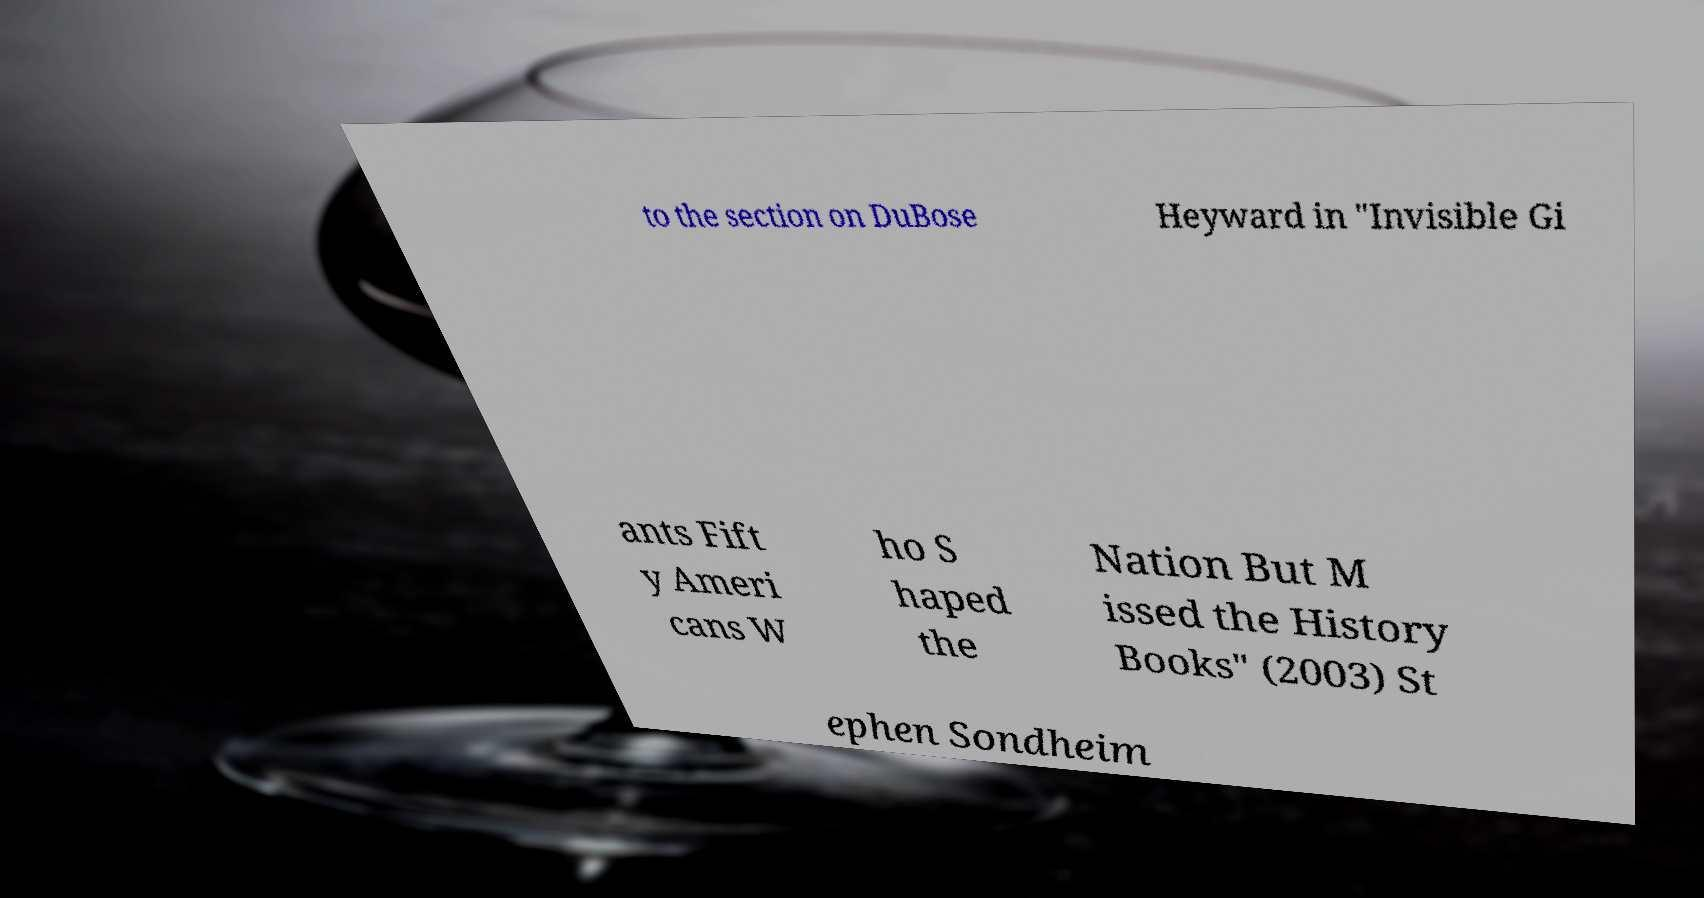For documentation purposes, I need the text within this image transcribed. Could you provide that? to the section on DuBose Heyward in "Invisible Gi ants Fift y Ameri cans W ho S haped the Nation But M issed the History Books" (2003) St ephen Sondheim 